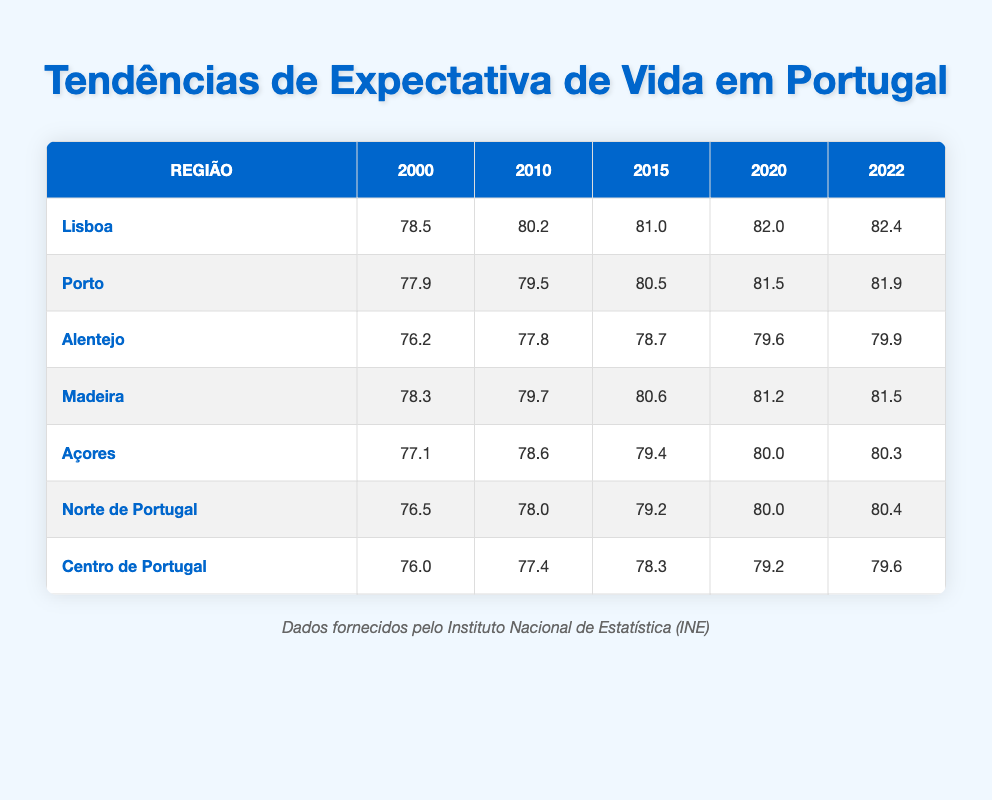What was the life expectancy in Lisbon in 2010? Looking at the table, the life expectancy in Lisbon for the year 2010 is directly listed as 80.2.
Answer: 80.2 Which region had the highest life expectancy in 2022? By comparing the life expectancy values for each region in 2022, Lisbon's life expectancy of 82.4 is the highest among all regions.
Answer: Lisbon What was the life expectancy increase in the Alentejo region from 2000 to 2022? To find the increase, subtract the life expectancy in 2000 (76.2) from that in 2022 (79.9). The calculation is 79.9 - 76.2 = 3.7.
Answer: 3.7 Did the life expectancy in Northern Portugal exceed 79 years in 2020? The table shows the life expectancy for Northern Portugal in 2020 is 80.0, which exceeds 79 years, so the answer is yes.
Answer: Yes What is the average life expectancy of all regions in 2022? To calculate the average, sum the life expectancy values for each region in 2022 (82.4 + 81.9 + 79.9 + 81.5 + 80.3 + 80.4 + 79.6) = 566.0, then divide by 7 (the number of regions), which results in 566.0 / 7 = 80.857, approximately 80.9.
Answer: 80.9 Which region had the lowest life expectancy in 2000, and what was that value? By reviewing the life expectancy figures for each region in 2000, Alentejo has the lowest value at 76.2.
Answer: Alentejo, 76.2 What is the difference in life expectancy between Porto and Madeira in 2015? For 2015, Porto's life expectancy is 80.5 and Madeira's is 80.6. Subtracting these, 80.6 - 80.5 = 0.1, indicating that Madeira had a slightly higher expectancy.
Answer: 0.1 How much did life expectancy in the Azores increase between 2010 and 2022? To find the increase in life expectancy in the Azores from 2010 (78.6) to 2022 (80.3), subtract: 80.3 - 78.6 = 1.7.
Answer: 1.7 